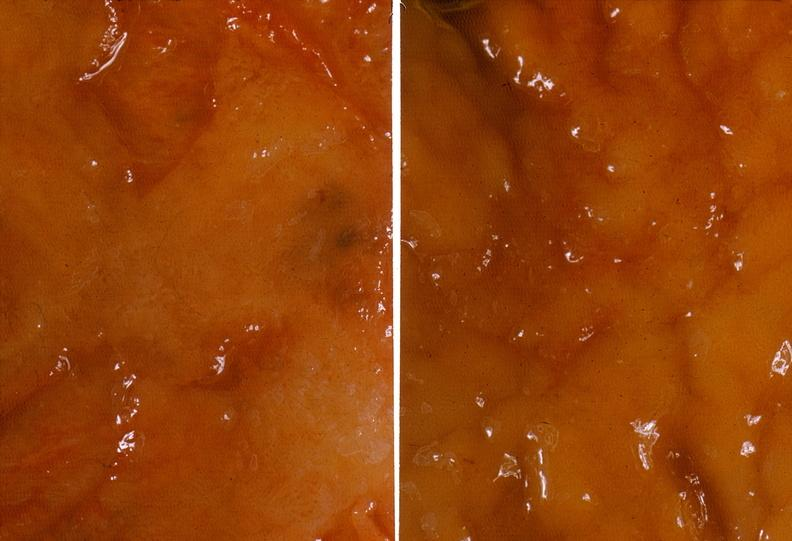s gastrointestinal present?
Answer the question using a single word or phrase. Yes 